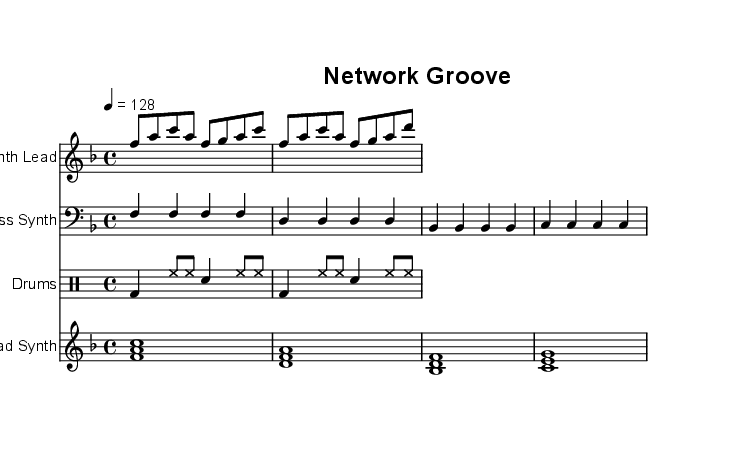What is the key signature of this music? The key signature is F major, which has one flat (B flat). This can be identified in the beginning of the score where the flats are shown.
Answer: F major What is the time signature of this music? The time signature is 4/4, which is indicated in the beginning of the score with the time signature symbol (4 over 4). This means there are four beats in each measure, and a quarter note gets one beat.
Answer: 4/4 What is the tempo marking of this music? The tempo marking is 128 beats per minute, indicated by "4 = 128" at the top of the score. This tells the performer the speed of the music.
Answer: 128 How many measures are in the synth lead section? The synth lead section contains two measures. This is determined by counting the groups of vertical lines (bar lines) in the staff that separate the measures.
Answer: 2 What type of drum pattern is used in this piece? The drum pattern is a basic beat with kick drums and hi-hats, typical of electronic dance music. This can be seen in the rhythmic notation showing bass drum (bd), hi-hat (hh), and snare (sn).
Answer: Basic beat What is the predominant instrument in this composition? The predominant instrument is the Synth Lead, as it usually carries the melody in electronic music tracks, which is confirmed by its placement at the top of the score and the recognizable melodic pattern.
Answer: Synth Lead 